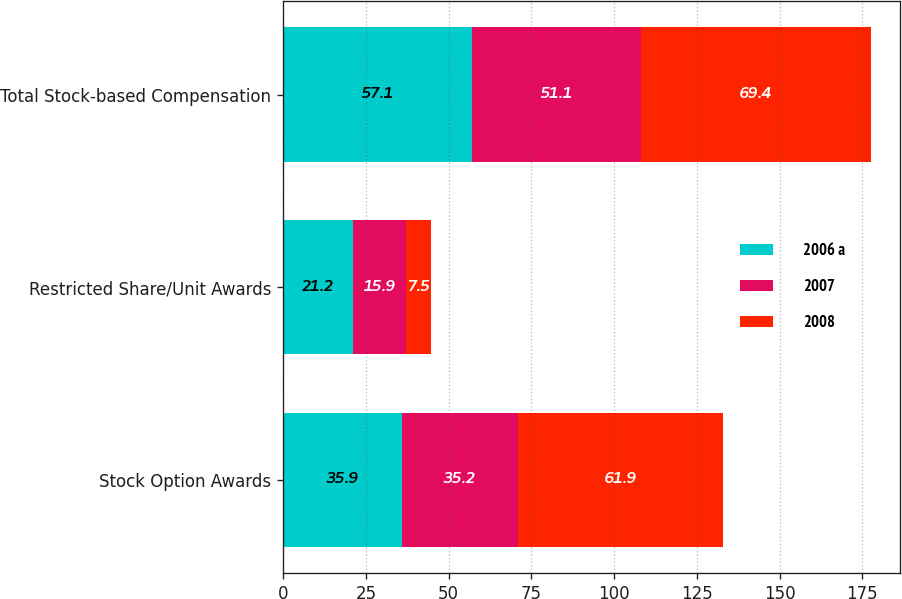Convert chart. <chart><loc_0><loc_0><loc_500><loc_500><stacked_bar_chart><ecel><fcel>Stock Option Awards<fcel>Restricted Share/Unit Awards<fcel>Total Stock-based Compensation<nl><fcel>2006 a<fcel>35.9<fcel>21.2<fcel>57.1<nl><fcel>2007<fcel>35.2<fcel>15.9<fcel>51.1<nl><fcel>2008<fcel>61.9<fcel>7.5<fcel>69.4<nl></chart> 